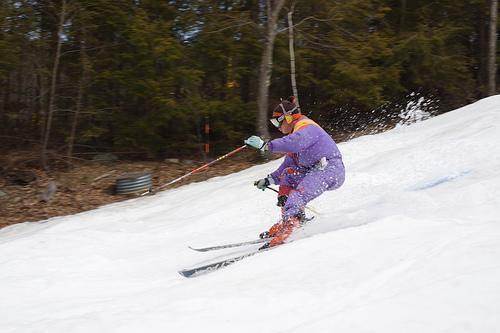How many apples are there?
Give a very brief answer. 0. 